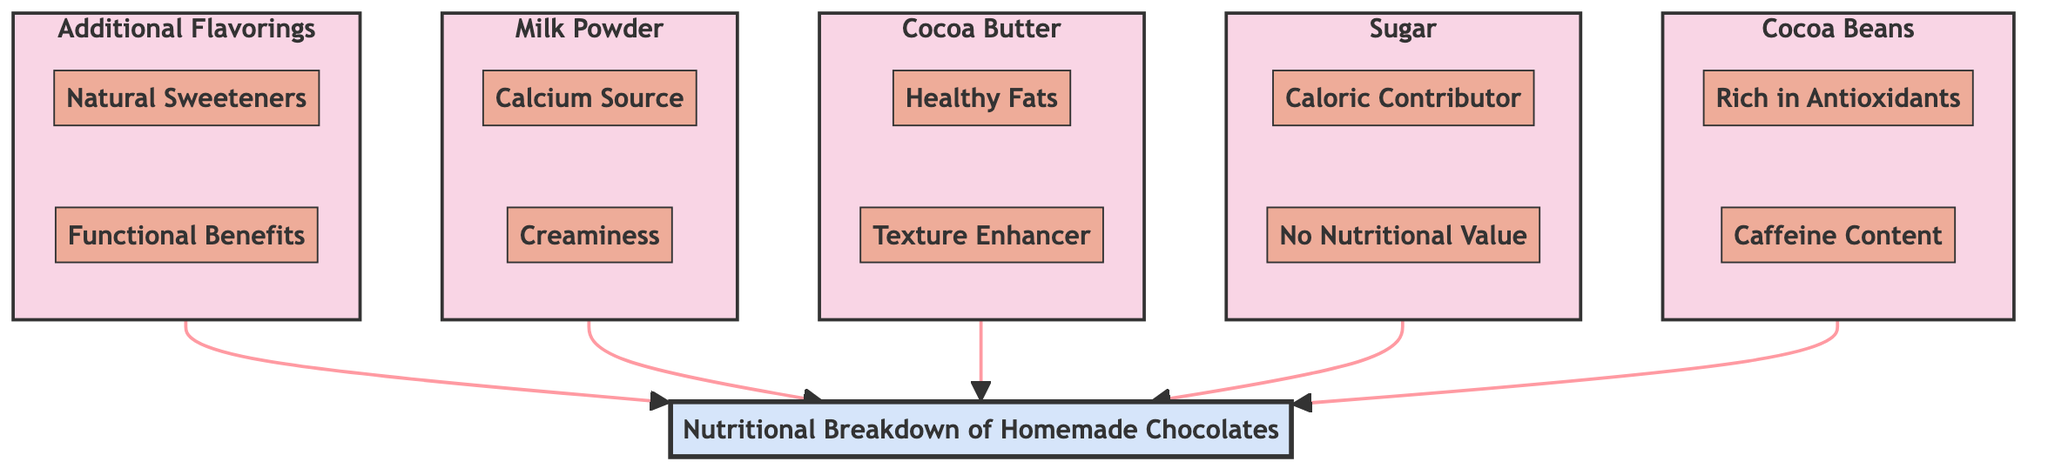What are the two sub-elements of Cocoa Beans? The diagram shows two sub-elements branching from Cocoa Beans: "Rich in Antioxidants" and "Caffeine Content."
Answer: Rich in Antioxidants, Caffeine Content How many main ingredient categories are presented in the diagram? The diagram lists five main ingredient categories: Cocoa Beans, Sugar, Cocoa Butter, Milk Powder, and Additional Flavorings.
Answer: 5 Which ingredient provides calcium? Looking at the diagram, the sub-element "Calcium Source" under Milk Powder indicates it provides calcium.
Answer: Milk Powder What is the relationship between Additional Flavorings and Nutritional Breakdown? The diagram shows that Additional Flavorings is a sub-element that connects to the main node Nutritional Breakdown, indicating it is a contributing factor.
Answer: Contributing factor What are the health benefits of Cocoa Butter? There are two sub-elements under Cocoa Butter: "Healthy Fats," which suggests health benefits, and "Texture Enhancer," which relates to the texture but not directly to health benefits.
Answer: Healthy Fats Which ingredient contains no nutritional value? The sub-element "No Nutritional Value" under Sugar indicates that this ingredient does not contribute nutritional value.
Answer: Sugar How does the diagram flow from the sub-elements to the main Nutritional Breakdown? Each category of ingredients has sub-elements that elaborate on specific health benefits or contributions, which then lead up to the main node Nutritional Breakdown, showcasing a bottom-up approach.
Answer: Bottom-up approach What functional benefit is associated with spices in Additional Flavorings? Under Additional Flavorings, the sub-element "Functional Benefits" mentions that spices like cinnamon may offer anti-inflammatory properties.
Answer: Anti-inflammatory properties 